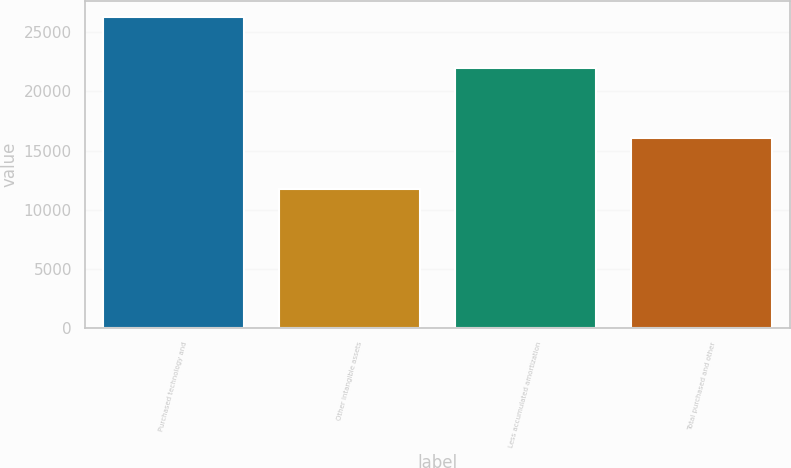Convert chart. <chart><loc_0><loc_0><loc_500><loc_500><bar_chart><fcel>Purchased technology and<fcel>Other intangible assets<fcel>Less accumulated amortization<fcel>Total purchased and other<nl><fcel>26304<fcel>11719<fcel>21956<fcel>16067<nl></chart> 